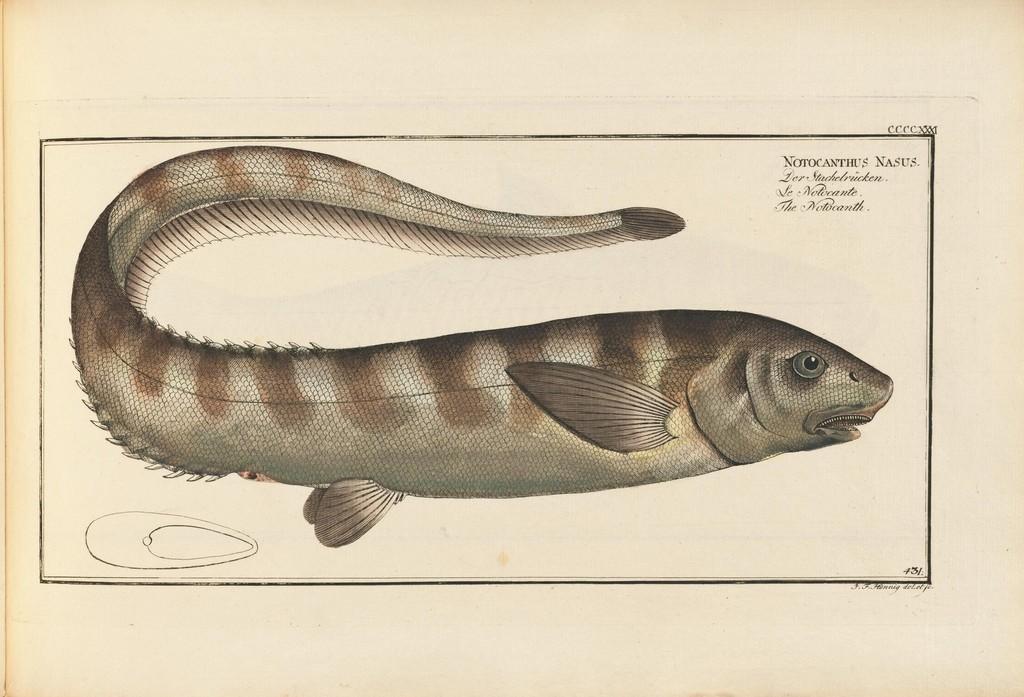Describe this image in one or two sentences. In this image we can see the picture of a fish on a paper. We can also see some text on it. 